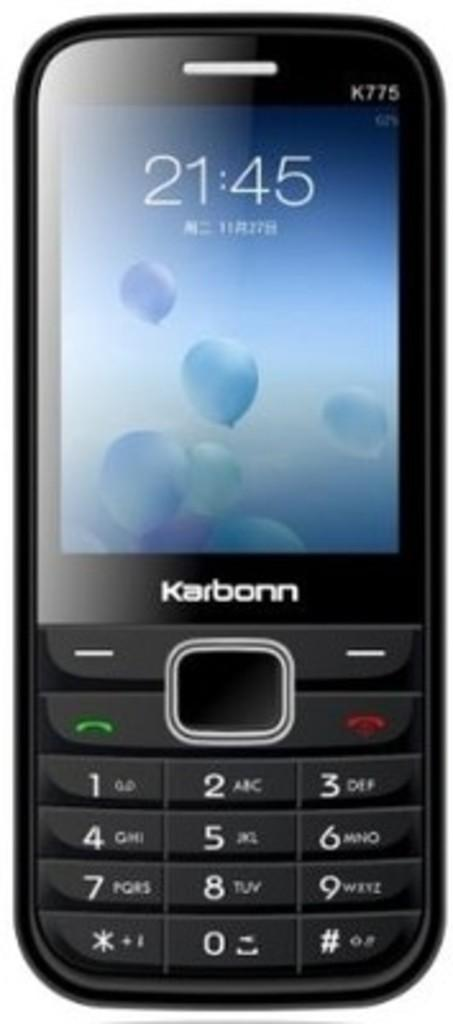Provide a one-sentence caption for the provided image. A Karbonn cell phone that has the time as 21:45. 